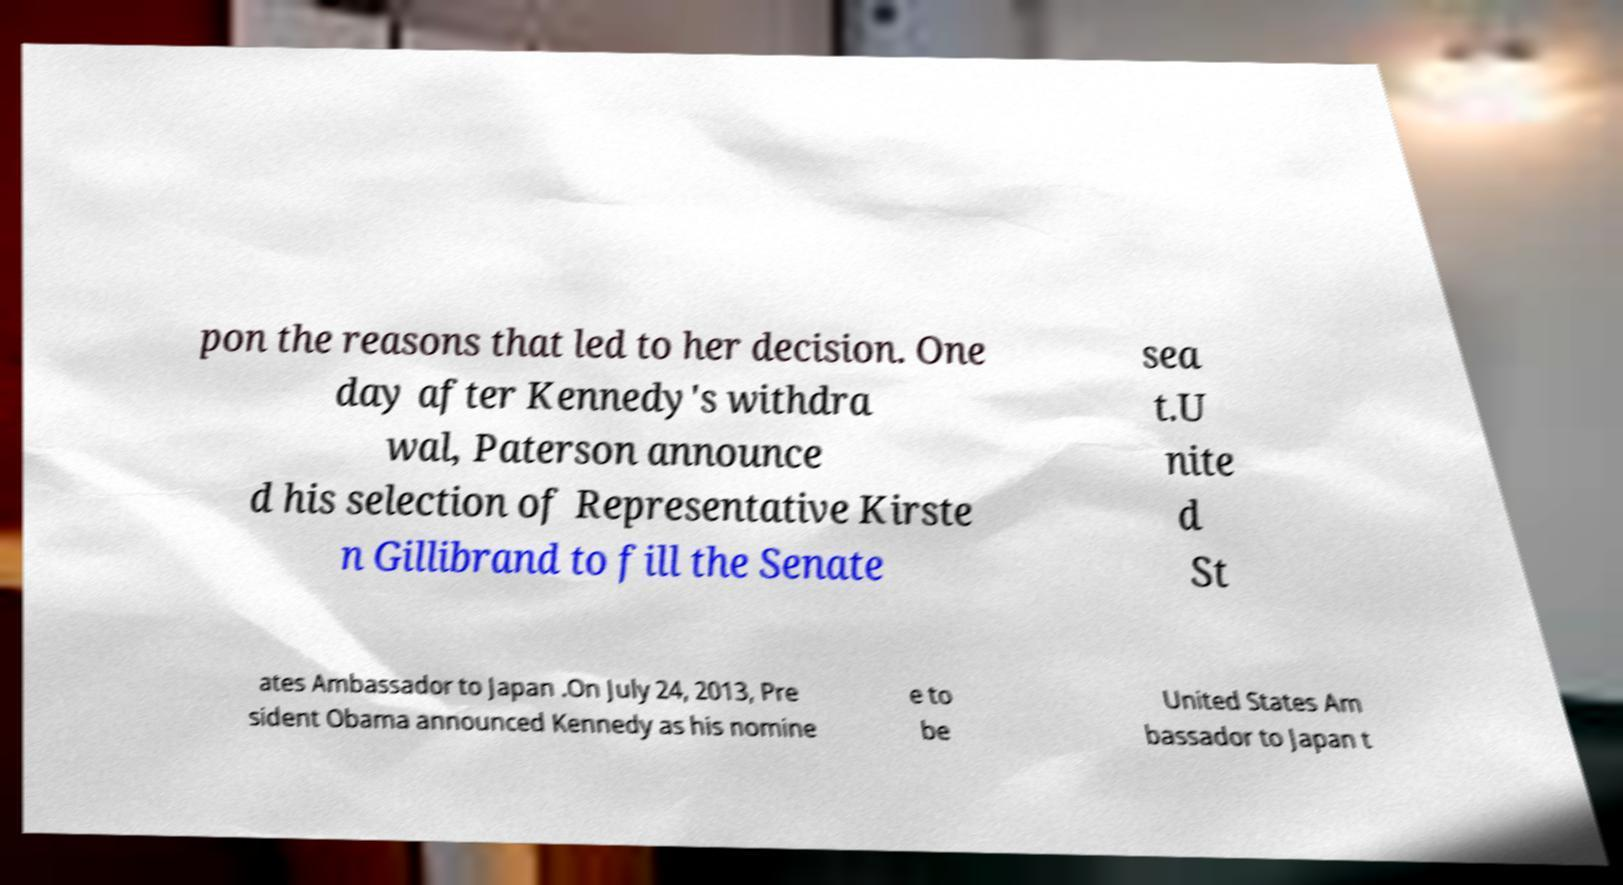Could you extract and type out the text from this image? pon the reasons that led to her decision. One day after Kennedy's withdra wal, Paterson announce d his selection of Representative Kirste n Gillibrand to fill the Senate sea t.U nite d St ates Ambassador to Japan .On July 24, 2013, Pre sident Obama announced Kennedy as his nomine e to be United States Am bassador to Japan t 